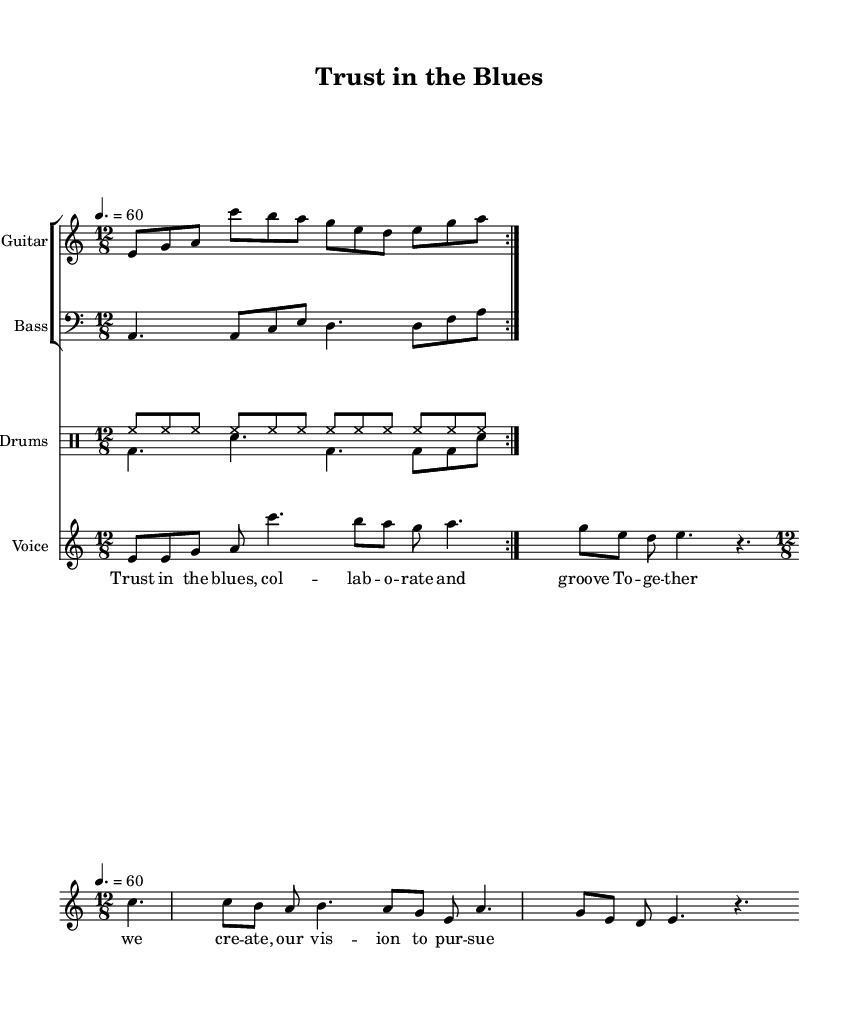What is the key signature of this music? The key signature is A minor, which has no sharps or flats. A minor is indicated at the beginning of the staff.
Answer: A minor What is the time signature of this piece? The time signature is 12/8, which indicates that there are 12 eighth notes in each measure, typically grouping them into four beats of three eighth notes. This can be found at the beginning of the music where the time signature is marked.
Answer: 12/8 What is the tempo marking for this track? The tempo marking is 60 beats per minute, indicated by the text "4. = 60" at the beginning of the score, which specifies the beat value and speed.
Answer: 60 How many measures are there in the verse? There are four measures in the verse, which can be counted by looking at the notation of the verse voice. Each distinct group of notes separated by bar lines represents one measure.
Answer: 4 What is the function of the drums in this piece? The drums provide rhythmic support and texture, with different patterns repeated for the verse and chorus sections. The up and down patterns of the drums serve to enhance the overall feel of collaboration and groove within the electric blues context.
Answer: Support and texture What do the lyrics in the verse emphasize? The lyrics "Trust in the blues, collaborate and groove" emphasize themes of collaboration and unity, highlighting the essence of working together, which is central to the narrative of the piece.
Answer: Collaboration What type of song structure is utilized in this piece? The song follows a verse-chorus structure, which is typical in blues music where a main theme is introduced in the verse followed by a repeated, often more uplifting chorus. The presence of distinct sections can be identified in the lyrics and notation.
Answer: Verse-chorus 